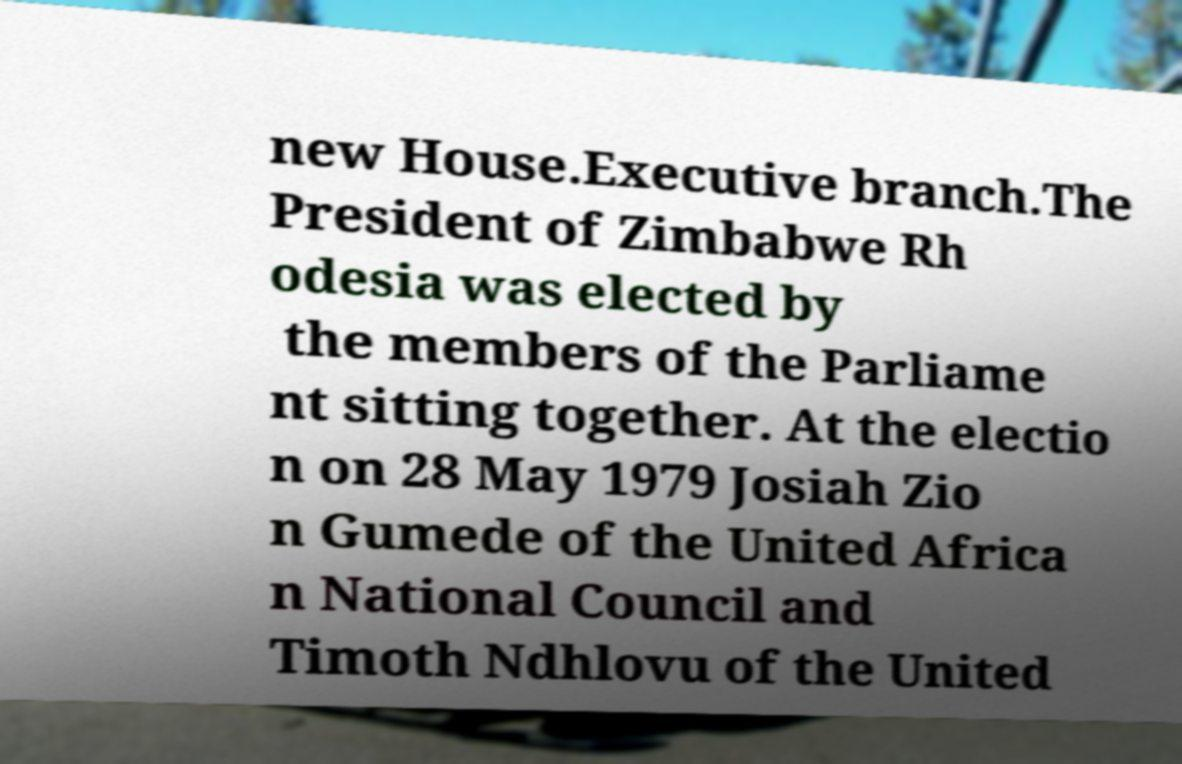Can you accurately transcribe the text from the provided image for me? new House.Executive branch.The President of Zimbabwe Rh odesia was elected by the members of the Parliame nt sitting together. At the electio n on 28 May 1979 Josiah Zio n Gumede of the United Africa n National Council and Timoth Ndhlovu of the United 